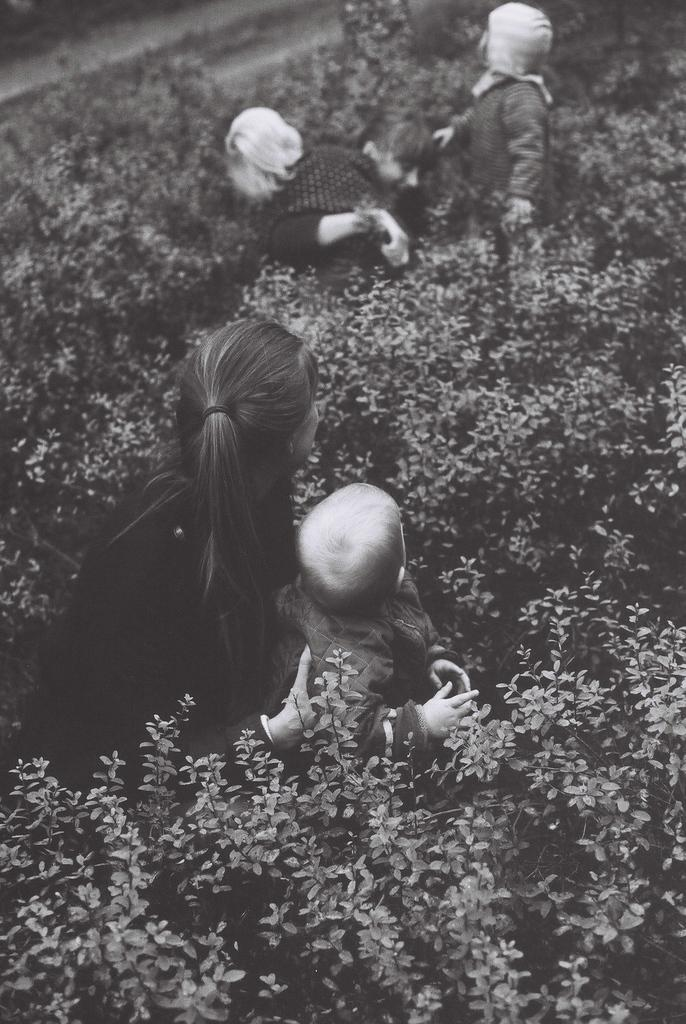What is the main subject of the image? The main subject of the image is a group of people. What else can be seen in the image besides the people? There are plants visible in the image. What is the color scheme of the image? The image is in black and white. What type of quilt is being used as a backdrop for the competition in the image? There is no quilt or competition present in the image; it features a group of people and plants in black and white. 